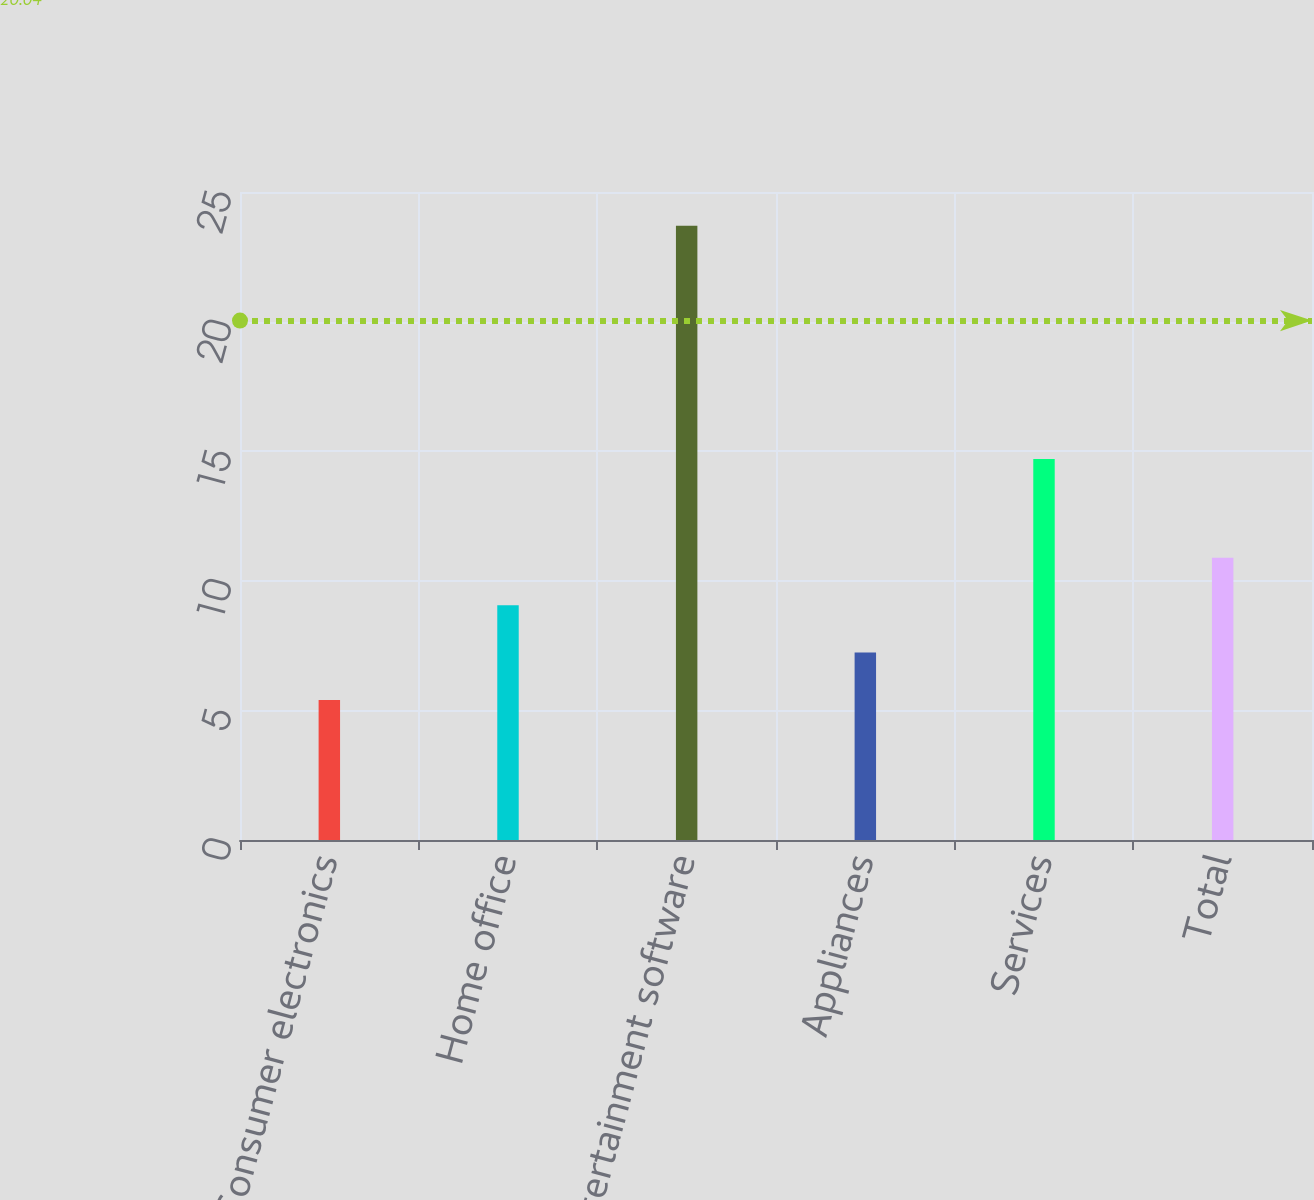<chart> <loc_0><loc_0><loc_500><loc_500><bar_chart><fcel>Consumer electronics<fcel>Home office<fcel>Entertainment software<fcel>Appliances<fcel>Services<fcel>Total<nl><fcel>5.4<fcel>9.06<fcel>23.7<fcel>7.23<fcel>14.7<fcel>10.89<nl></chart> 